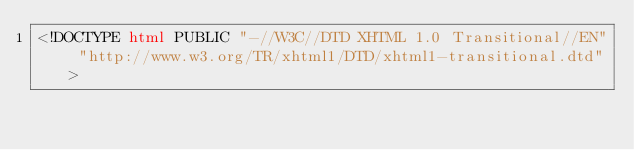<code> <loc_0><loc_0><loc_500><loc_500><_HTML_><!DOCTYPE html PUBLIC "-//W3C//DTD XHTML 1.0 Transitional//EN" "http://www.w3.org/TR/xhtml1/DTD/xhtml1-transitional.dtd"></code> 